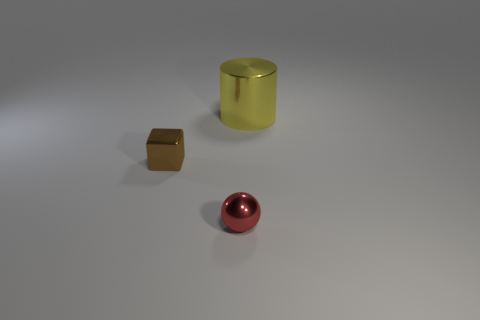Is there anything else that is the same size as the cylinder?
Give a very brief answer. No. Are there any other things that have the same shape as the yellow thing?
Make the answer very short. No. Do the small metallic thing right of the brown object and the small metal cube have the same color?
Your answer should be very brief. No. There is a object that is in front of the yellow cylinder and behind the sphere; what material is it?
Provide a succinct answer. Metal. Are there more small shiny blocks than big gray metal cylinders?
Your answer should be very brief. Yes. The metallic object that is on the right side of the small object to the right of the tiny brown cube left of the red thing is what color?
Your answer should be compact. Yellow. Does the object right of the red object have the same material as the tiny brown object?
Your answer should be compact. Yes. Are any big red balls visible?
Keep it short and to the point. No. There is a metal cylinder behind the brown metal block; does it have the same size as the small brown shiny block?
Give a very brief answer. No. Are there fewer small brown things than tiny green blocks?
Keep it short and to the point. No. 